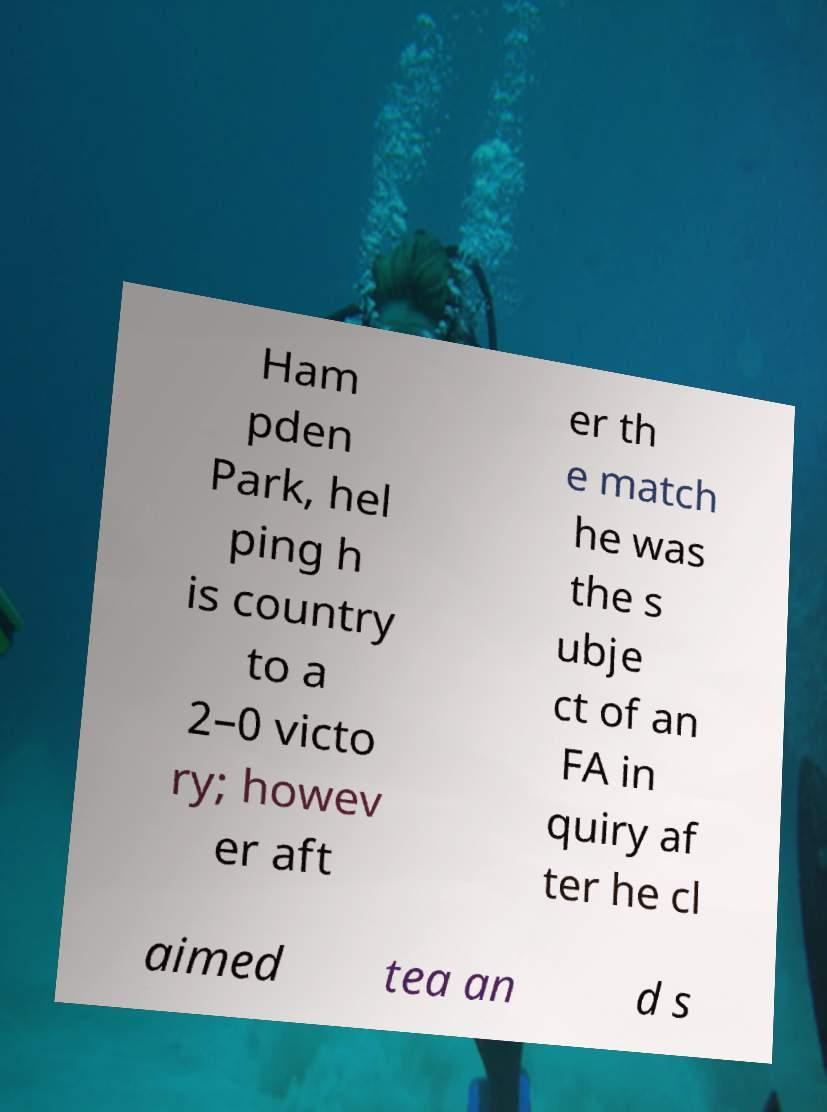For documentation purposes, I need the text within this image transcribed. Could you provide that? Ham pden Park, hel ping h is country to a 2–0 victo ry; howev er aft er th e match he was the s ubje ct of an FA in quiry af ter he cl aimed tea an d s 